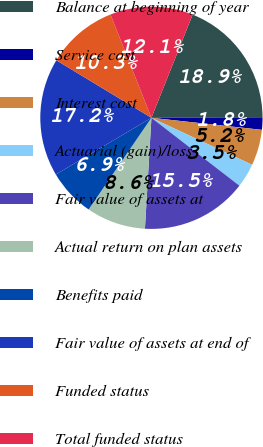Convert chart to OTSL. <chart><loc_0><loc_0><loc_500><loc_500><pie_chart><fcel>Balance at beginning of year<fcel>Service cost<fcel>Interest cost<fcel>Actuarial (gain)/loss<fcel>Fair value of assets at<fcel>Actual return on plan assets<fcel>Benefits paid<fcel>Fair value of assets at end of<fcel>Funded status<fcel>Total funded status<nl><fcel>18.88%<fcel>1.8%<fcel>5.22%<fcel>3.51%<fcel>15.47%<fcel>8.63%<fcel>6.92%<fcel>17.18%<fcel>10.34%<fcel>12.05%<nl></chart> 